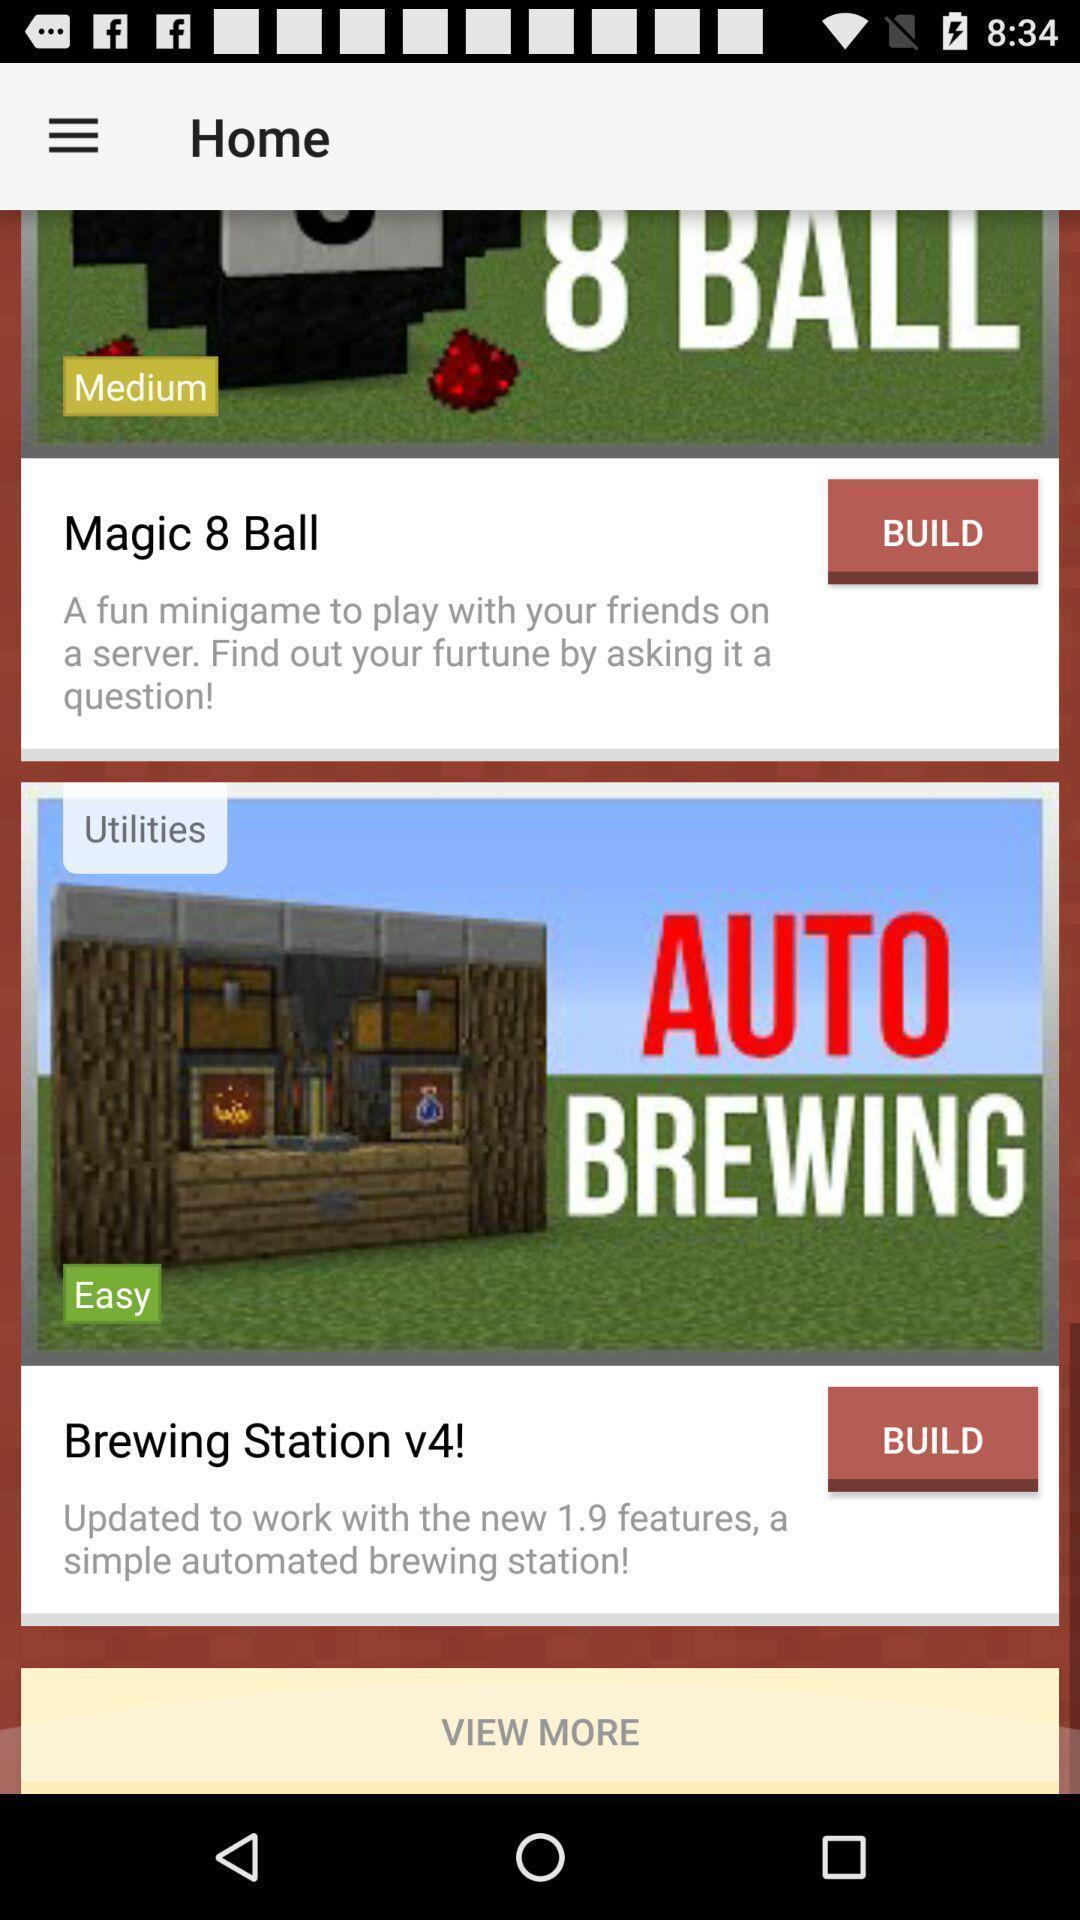What is the overall content of this screenshot? Page showing multiple games on app. 